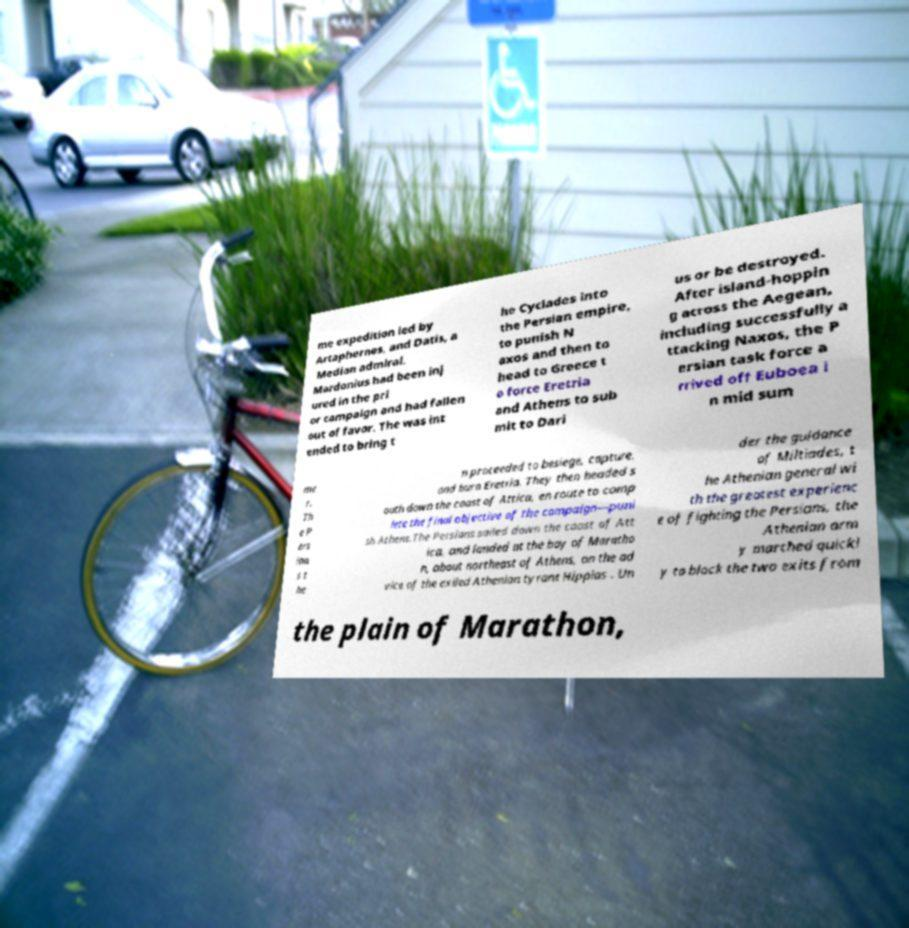Please read and relay the text visible in this image. What does it say? me expedition led by Artaphernes, and Datis, a Median admiral. Mardonius had been inj ured in the pri or campaign and had fallen out of favor. The was int ended to bring t he Cyclades into the Persian empire, to punish N axos and then to head to Greece t o force Eretria and Athens to sub mit to Dari us or be destroyed. After island-hoppin g across the Aegean, including successfully a ttacking Naxos, the P ersian task force a rrived off Euboea i n mid sum me r. Th e P ers ian s t he n proceeded to besiege, capture, and burn Eretria. They then headed s outh down the coast of Attica, en route to comp lete the final objective of the campaign—puni sh Athens.The Persians sailed down the coast of Att ica, and landed at the bay of Maratho n, about northeast of Athens, on the ad vice of the exiled Athenian tyrant Hippias . Un der the guidance of Miltiades, t he Athenian general wi th the greatest experienc e of fighting the Persians, the Athenian arm y marched quickl y to block the two exits from the plain of Marathon, 